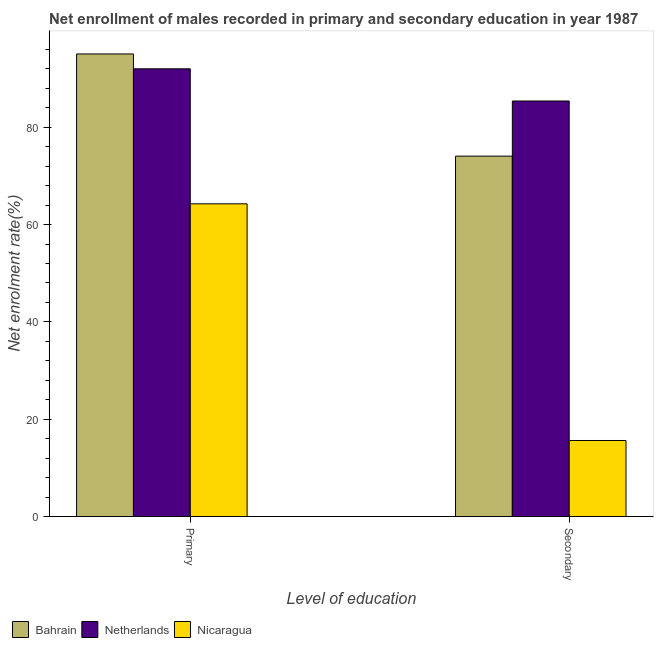How many different coloured bars are there?
Provide a short and direct response. 3. What is the label of the 1st group of bars from the left?
Your answer should be compact. Primary. What is the enrollment rate in secondary education in Nicaragua?
Offer a very short reply. 15.63. Across all countries, what is the maximum enrollment rate in secondary education?
Your answer should be compact. 85.39. Across all countries, what is the minimum enrollment rate in primary education?
Provide a short and direct response. 64.26. In which country was the enrollment rate in secondary education maximum?
Keep it short and to the point. Netherlands. In which country was the enrollment rate in secondary education minimum?
Ensure brevity in your answer.  Nicaragua. What is the total enrollment rate in primary education in the graph?
Offer a terse response. 251.32. What is the difference between the enrollment rate in secondary education in Nicaragua and that in Netherlands?
Provide a short and direct response. -69.76. What is the difference between the enrollment rate in primary education in Netherlands and the enrollment rate in secondary education in Nicaragua?
Ensure brevity in your answer.  76.38. What is the average enrollment rate in secondary education per country?
Your answer should be very brief. 58.36. What is the difference between the enrollment rate in primary education and enrollment rate in secondary education in Netherlands?
Your answer should be compact. 6.62. In how many countries, is the enrollment rate in primary education greater than 8 %?
Offer a very short reply. 3. What is the ratio of the enrollment rate in primary education in Nicaragua to that in Netherlands?
Offer a terse response. 0.7. In how many countries, is the enrollment rate in primary education greater than the average enrollment rate in primary education taken over all countries?
Make the answer very short. 2. What does the 3rd bar from the left in Primary represents?
Ensure brevity in your answer.  Nicaragua. How many bars are there?
Provide a short and direct response. 6. Are all the bars in the graph horizontal?
Provide a succinct answer. No. What is the difference between two consecutive major ticks on the Y-axis?
Your answer should be compact. 20. Where does the legend appear in the graph?
Provide a succinct answer. Bottom left. How many legend labels are there?
Offer a very short reply. 3. What is the title of the graph?
Offer a very short reply. Net enrollment of males recorded in primary and secondary education in year 1987. What is the label or title of the X-axis?
Your response must be concise. Level of education. What is the label or title of the Y-axis?
Your response must be concise. Net enrolment rate(%). What is the Net enrolment rate(%) of Bahrain in Primary?
Provide a succinct answer. 95.06. What is the Net enrolment rate(%) of Netherlands in Primary?
Your response must be concise. 92. What is the Net enrolment rate(%) in Nicaragua in Primary?
Your answer should be compact. 64.26. What is the Net enrolment rate(%) in Bahrain in Secondary?
Your answer should be compact. 74.06. What is the Net enrolment rate(%) in Netherlands in Secondary?
Your answer should be very brief. 85.39. What is the Net enrolment rate(%) of Nicaragua in Secondary?
Provide a succinct answer. 15.63. Across all Level of education, what is the maximum Net enrolment rate(%) of Bahrain?
Offer a terse response. 95.06. Across all Level of education, what is the maximum Net enrolment rate(%) in Netherlands?
Offer a terse response. 92. Across all Level of education, what is the maximum Net enrolment rate(%) of Nicaragua?
Offer a very short reply. 64.26. Across all Level of education, what is the minimum Net enrolment rate(%) in Bahrain?
Make the answer very short. 74.06. Across all Level of education, what is the minimum Net enrolment rate(%) of Netherlands?
Provide a short and direct response. 85.39. Across all Level of education, what is the minimum Net enrolment rate(%) in Nicaragua?
Ensure brevity in your answer.  15.63. What is the total Net enrolment rate(%) in Bahrain in the graph?
Offer a terse response. 169.12. What is the total Net enrolment rate(%) in Netherlands in the graph?
Keep it short and to the point. 177.39. What is the total Net enrolment rate(%) in Nicaragua in the graph?
Your answer should be very brief. 79.89. What is the difference between the Net enrolment rate(%) of Bahrain in Primary and that in Secondary?
Your response must be concise. 21. What is the difference between the Net enrolment rate(%) in Netherlands in Primary and that in Secondary?
Provide a short and direct response. 6.62. What is the difference between the Net enrolment rate(%) in Nicaragua in Primary and that in Secondary?
Keep it short and to the point. 48.63. What is the difference between the Net enrolment rate(%) in Bahrain in Primary and the Net enrolment rate(%) in Netherlands in Secondary?
Keep it short and to the point. 9.67. What is the difference between the Net enrolment rate(%) in Bahrain in Primary and the Net enrolment rate(%) in Nicaragua in Secondary?
Make the answer very short. 79.43. What is the difference between the Net enrolment rate(%) in Netherlands in Primary and the Net enrolment rate(%) in Nicaragua in Secondary?
Offer a terse response. 76.38. What is the average Net enrolment rate(%) of Bahrain per Level of education?
Your answer should be very brief. 84.56. What is the average Net enrolment rate(%) in Netherlands per Level of education?
Your answer should be very brief. 88.7. What is the average Net enrolment rate(%) in Nicaragua per Level of education?
Keep it short and to the point. 39.94. What is the difference between the Net enrolment rate(%) in Bahrain and Net enrolment rate(%) in Netherlands in Primary?
Offer a terse response. 3.05. What is the difference between the Net enrolment rate(%) in Bahrain and Net enrolment rate(%) in Nicaragua in Primary?
Ensure brevity in your answer.  30.8. What is the difference between the Net enrolment rate(%) in Netherlands and Net enrolment rate(%) in Nicaragua in Primary?
Your answer should be compact. 27.74. What is the difference between the Net enrolment rate(%) in Bahrain and Net enrolment rate(%) in Netherlands in Secondary?
Provide a succinct answer. -11.33. What is the difference between the Net enrolment rate(%) in Bahrain and Net enrolment rate(%) in Nicaragua in Secondary?
Provide a short and direct response. 58.44. What is the difference between the Net enrolment rate(%) in Netherlands and Net enrolment rate(%) in Nicaragua in Secondary?
Provide a succinct answer. 69.76. What is the ratio of the Net enrolment rate(%) in Bahrain in Primary to that in Secondary?
Offer a terse response. 1.28. What is the ratio of the Net enrolment rate(%) of Netherlands in Primary to that in Secondary?
Give a very brief answer. 1.08. What is the ratio of the Net enrolment rate(%) of Nicaragua in Primary to that in Secondary?
Your response must be concise. 4.11. What is the difference between the highest and the second highest Net enrolment rate(%) of Bahrain?
Keep it short and to the point. 21. What is the difference between the highest and the second highest Net enrolment rate(%) in Netherlands?
Give a very brief answer. 6.62. What is the difference between the highest and the second highest Net enrolment rate(%) of Nicaragua?
Ensure brevity in your answer.  48.63. What is the difference between the highest and the lowest Net enrolment rate(%) of Bahrain?
Ensure brevity in your answer.  21. What is the difference between the highest and the lowest Net enrolment rate(%) of Netherlands?
Your answer should be very brief. 6.62. What is the difference between the highest and the lowest Net enrolment rate(%) of Nicaragua?
Offer a terse response. 48.63. 